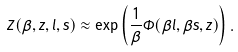Convert formula to latex. <formula><loc_0><loc_0><loc_500><loc_500>Z ( \beta , z , l , s ) \approx \exp \left ( \frac { 1 } { \beta } \Phi ( \beta l , \beta s , z ) \right ) .</formula> 